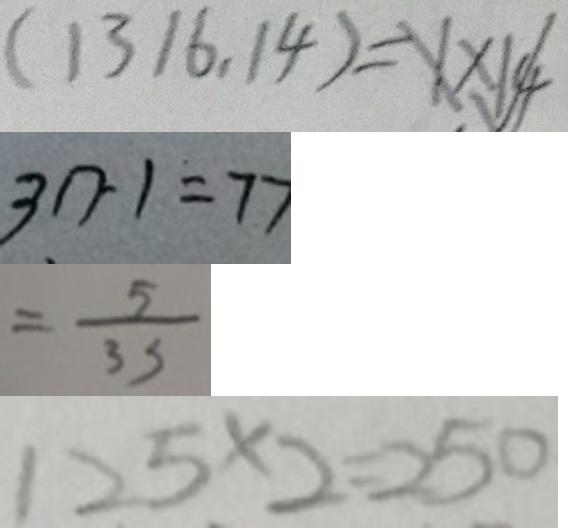<formula> <loc_0><loc_0><loc_500><loc_500>( 1 3 1 6 , 1 4 ) = X \times 1 4 √ 
 3 n - 1 = 7 7 
 = \frac { 5 } { 3 3 } 
 1 2 5 \times 2 = 2 5 0</formula> 